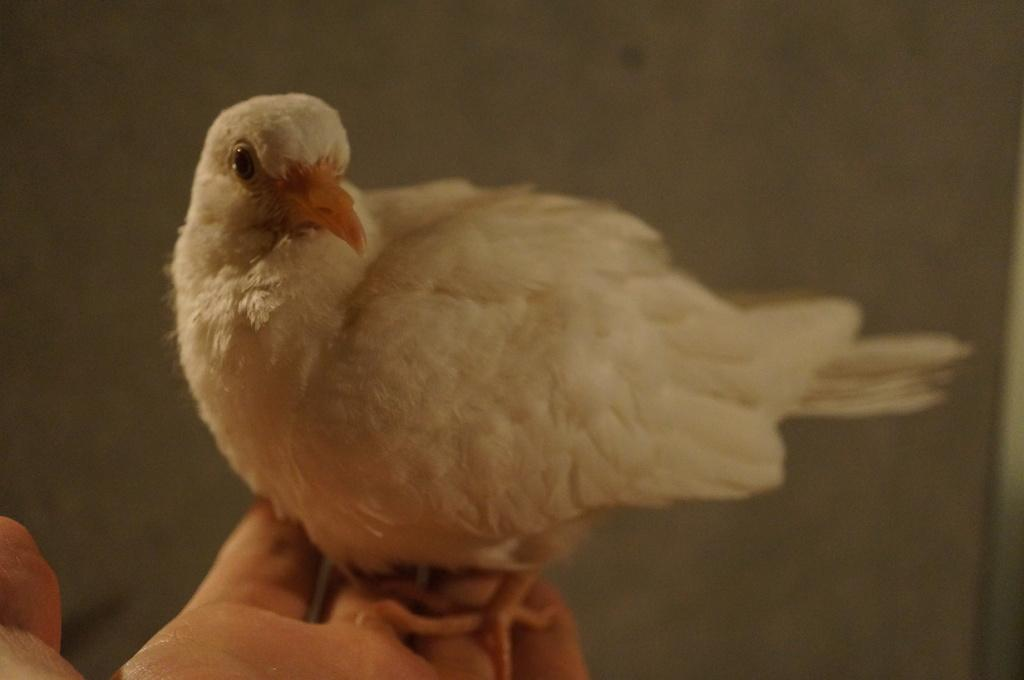What type of animal can be seen in the image? There is a white bird in the image. Where is the bird located in the image? The bird is on a person's hand. What can be seen in the background of the image? There is a wall visible in the background of the image. What type of riddle can be solved using the rice in the image? There is no rice present in the image, and therefore no riddle can be solved using it. 